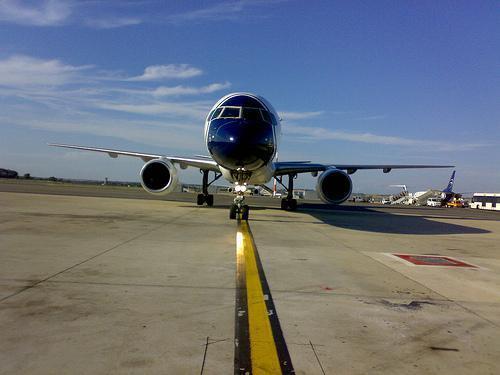How many planes are clearly featured?
Give a very brief answer. 1. 